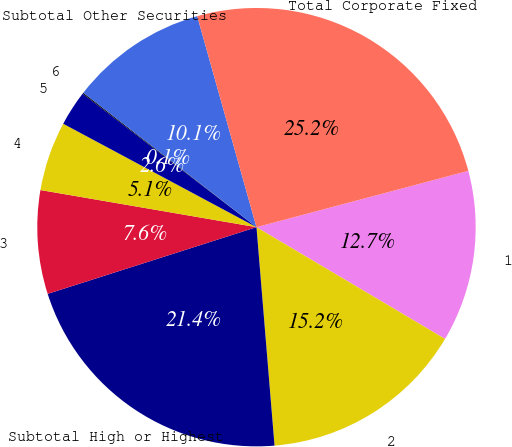<chart> <loc_0><loc_0><loc_500><loc_500><pie_chart><fcel>1<fcel>2<fcel>Subtotal High or Highest<fcel>3<fcel>4<fcel>5<fcel>6<fcel>Subtotal Other Securities<fcel>Total Corporate Fixed<nl><fcel>12.65%<fcel>15.17%<fcel>21.39%<fcel>7.63%<fcel>5.11%<fcel>2.6%<fcel>0.08%<fcel>10.14%<fcel>25.22%<nl></chart> 